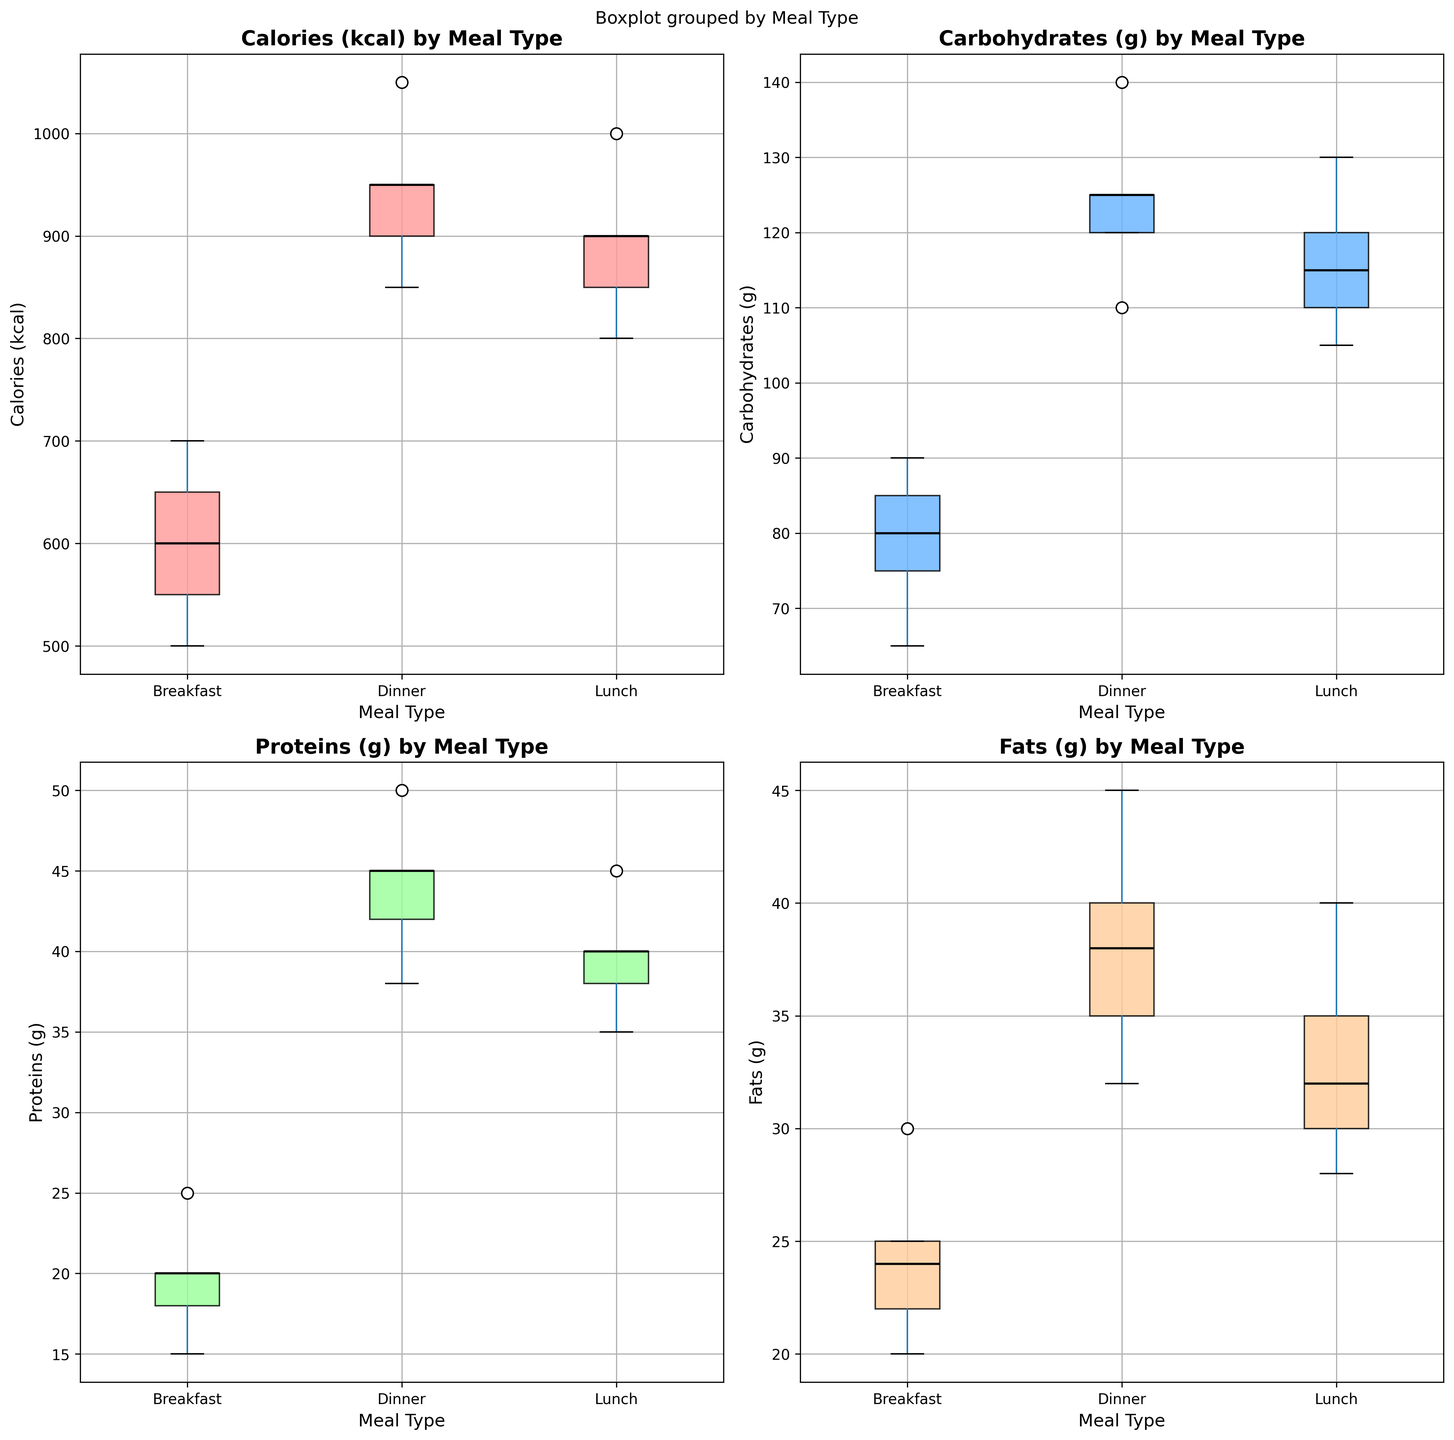What is the title of the figure? The title of the figure is placed at the top and is usually the largest and boldest text to indicate the main subject of the visualization.
Answer: Nutritional Intake Variations Among Professional Athletes What nutrients are shown in the box plots? The titles of each subplot indicate the specific nutrients being analyzed.
Answer: Calories (kcal), Carbohydrates (g), Proteins (g), Fats (g) Which meal type has the highest median Calories (kcal)? By looking at the box plot for Calories (kcal), you can see the position of the median line inside each box. The meal with the highest median line is the one with the highest median calorie intake.
Answer: Dinner Is there more variability in Carbohydrates (g) intake at lunch or dinner? Variability is represented by the spread of the box and whiskers in the box plot. Compare the spreads of the lunch and dinner box plots for Carbohydrates (g).
Answer: Dinner Which athlete appears to have a higher median protein intake for dinner according to the plot? The protein intake for dinner can be compared by observing where the median lines fall inside the boxes for each athlete under the 'Dinner' category.
Answer: Usain Bolt What are the ranges of Fats (g) intake for breakfast? The range (difference between the maximum and minimum) is seen in the box plot whiskers for Fats (g) under the Breakfast category.
Answer: 20g - 30g Are carbohydrates consistent across different meal types? Consistency can be assessed by looking at the spread and overlap of the boxes for each meal type in the Carbohydrates (g) box plot.
Answer: No How does the median protein intake at lunch compare to dinner? Comparing the median lines (black lines) of the lunch and dinner boxes in the Proteins (g) plot will show which meal has a higher or lower median protein intake.
Answer: Dinner median is higher Does any meal type show an outlier for Fats (g) intake? Outliers are depicted as individual points outside the whiskers. Check each box plot for Fats (g) to see if any meal type exhibits isolated points.
Answer: No outliers visible Which nutrient shows the highest variation across meal types? The highest variation is marked by the widest range from the minimum to the maximum among all nutrients across the meal types. By comparing the box and whiskers' lengths, one can assess this.
Answer: Calories (kcal) 